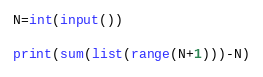Convert code to text. <code><loc_0><loc_0><loc_500><loc_500><_Python_>N=int(input())

print(sum(list(range(N+1)))-N)
</code> 